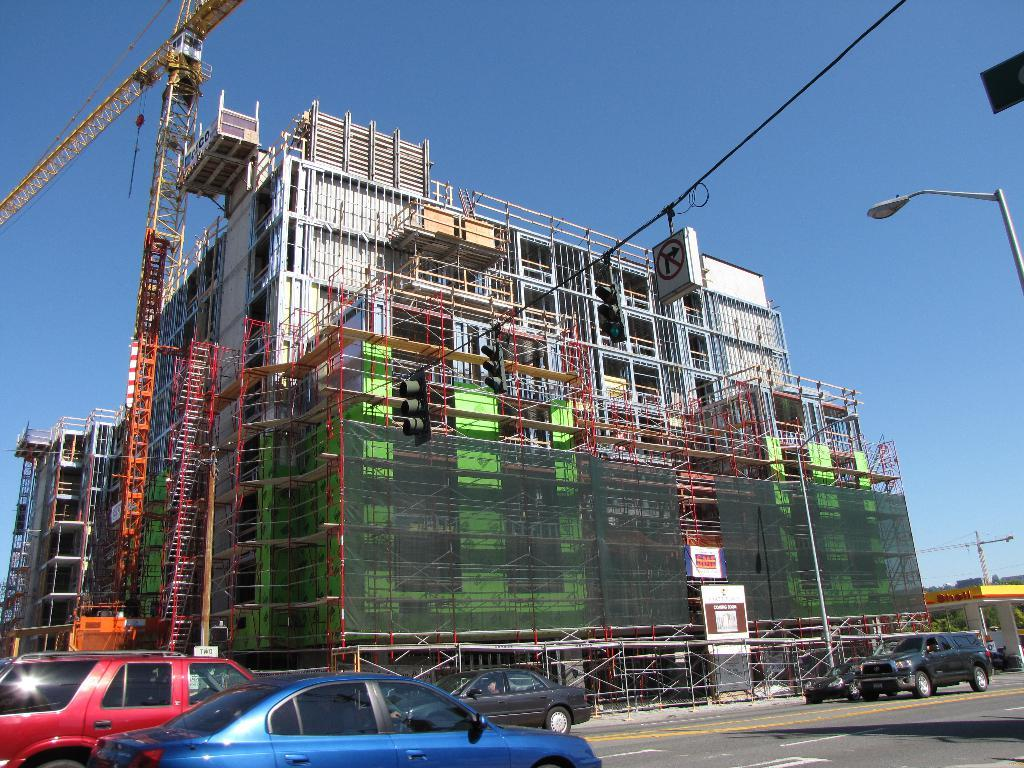What type of machinery is present in the image? There is a crane in the image. What other structures can be seen in the image? There is a light pole, traffic signals, a signboard, and buildings in the image. What is the condition of the road in the image? There are vehicles on the road in the image. What is the color of the sky in the image? The sky is blue in the image. Where is the branch that the pail is hanging from in the image? There is no branch or pail present in the image. 